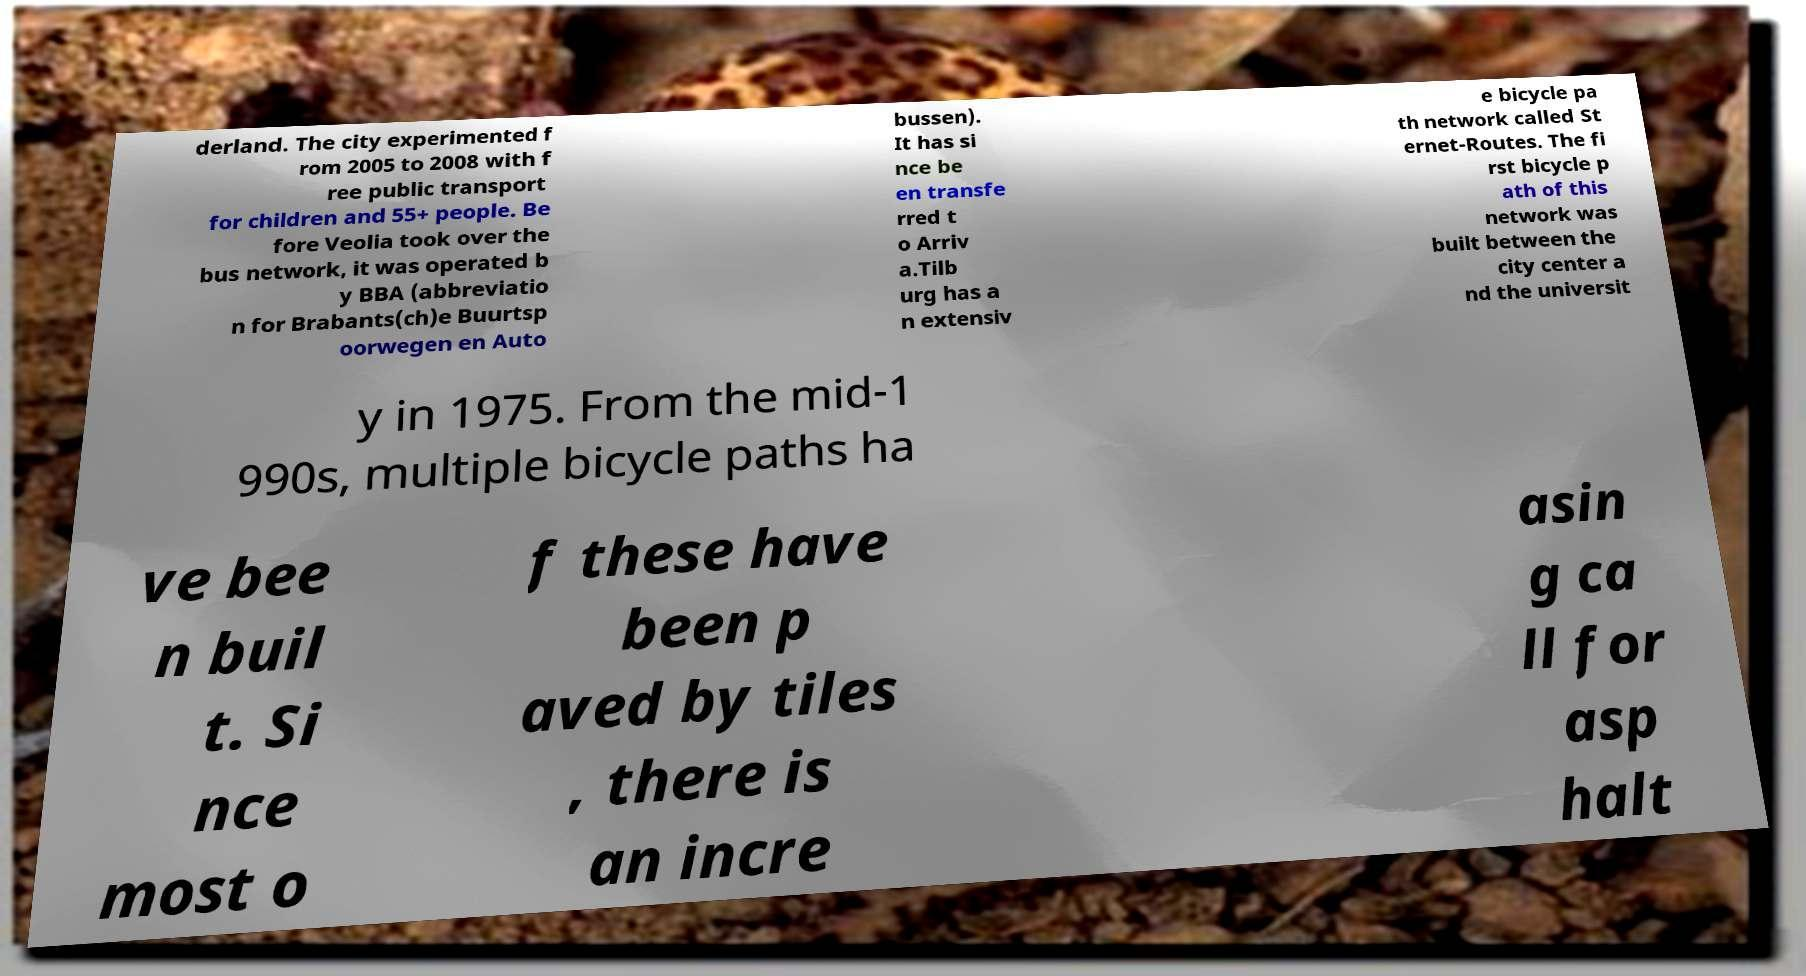What messages or text are displayed in this image? I need them in a readable, typed format. derland. The city experimented f rom 2005 to 2008 with f ree public transport for children and 55+ people. Be fore Veolia took over the bus network, it was operated b y BBA (abbreviatio n for Brabants(ch)e Buurtsp oorwegen en Auto bussen). It has si nce be en transfe rred t o Arriv a.Tilb urg has a n extensiv e bicycle pa th network called St ernet-Routes. The fi rst bicycle p ath of this network was built between the city center a nd the universit y in 1975. From the mid-1 990s, multiple bicycle paths ha ve bee n buil t. Si nce most o f these have been p aved by tiles , there is an incre asin g ca ll for asp halt 